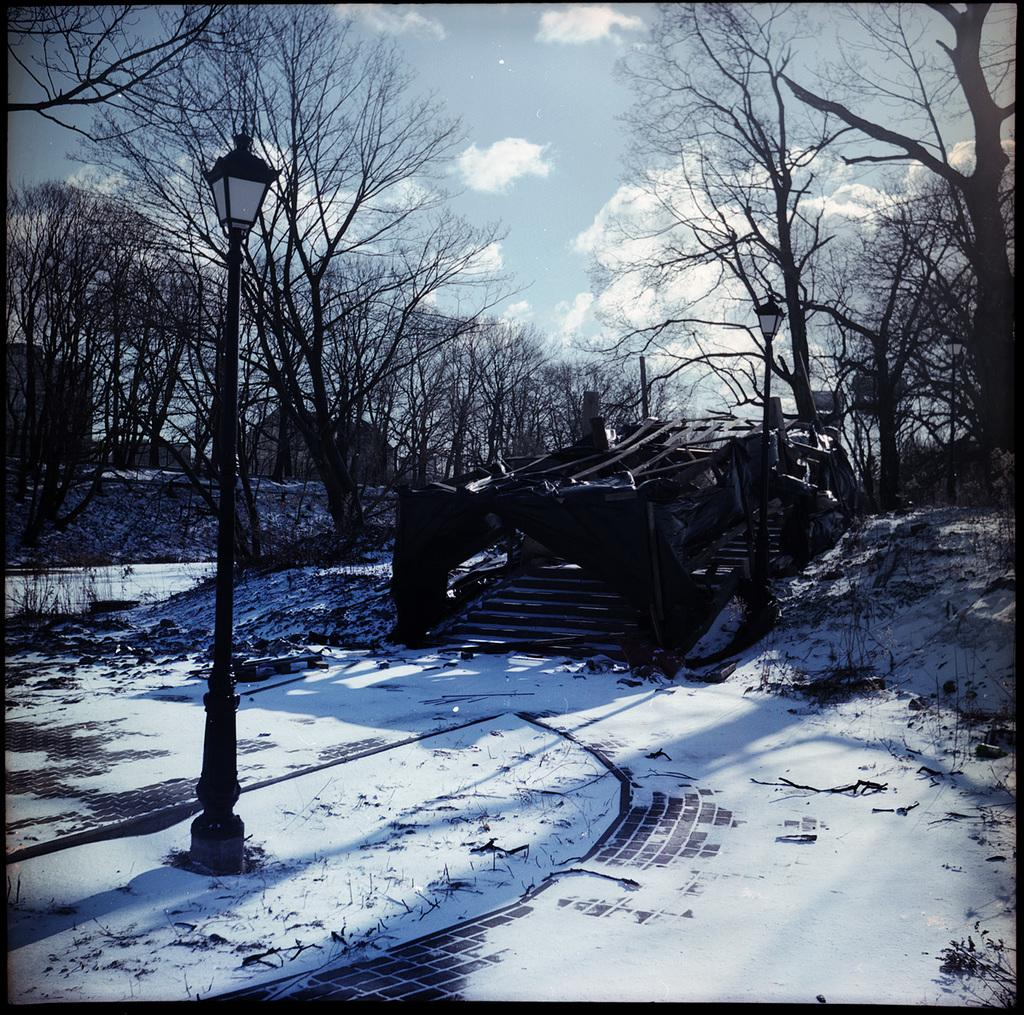What type of lighting fixture is present in the image? There is a street lamp in the image. What weather condition is depicted in the image? There is snow in the image. Are there any architectural features in the image? Yes, there are stairs in the image. What type of vegetation is visible in the image? There are trees in the image. What is visible in the sky in the image? The sky is visible in the image, and clouds are present. How would you describe the overall lighting in the image? The image is dark. How many roses are growing on the trees in the image? There are no roses present in the image; it features trees with snow. Can you tell me how many cats are sitting on the stairs in the image? There are no cats present in the image; it features stairs with snow. 